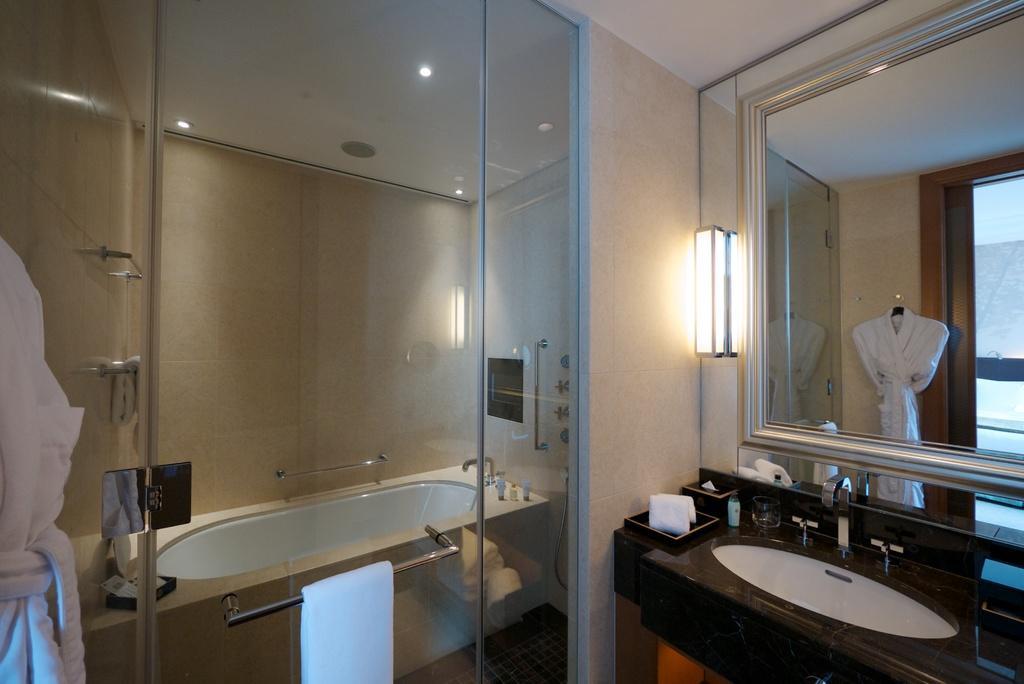In one or two sentences, can you explain what this image depicts? In this picture I can observe bathtub and towel bar fixed to this tub. On the right side I can observe mirror and sink. In the background I can observe a wall. 